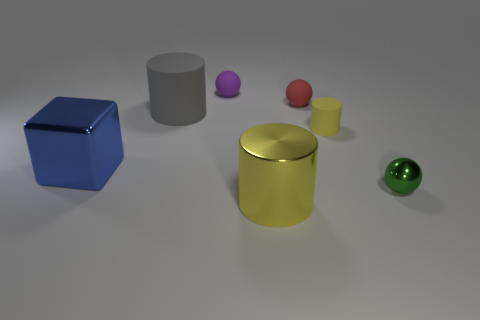What number of big blue objects are to the right of the rubber cylinder that is to the right of the red object? There are no big blue objects to the right of the rubber cylinder which is to the right of the red object. The big blue object, a cube, is actually situated to the left of the gray cylinder. 